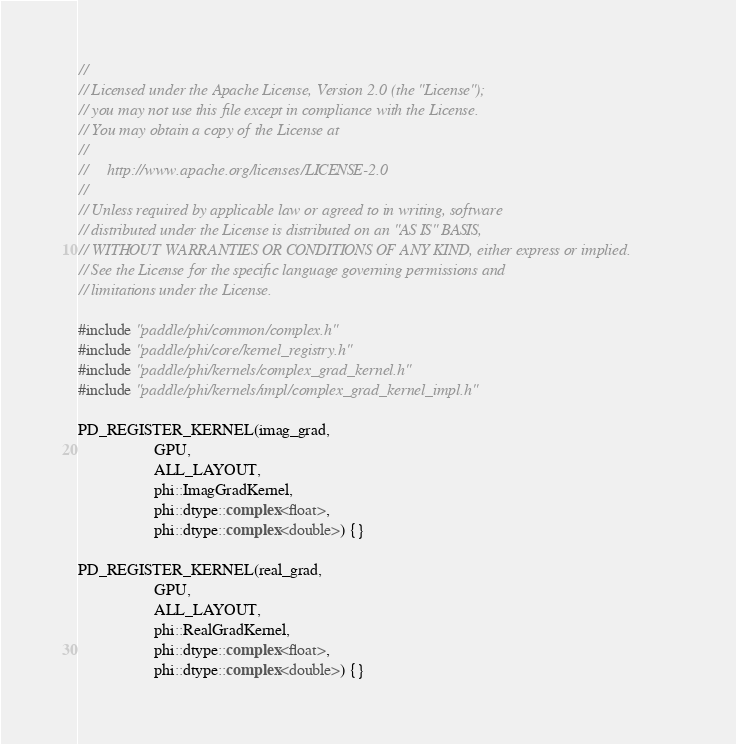Convert code to text. <code><loc_0><loc_0><loc_500><loc_500><_Cuda_>//
// Licensed under the Apache License, Version 2.0 (the "License");
// you may not use this file except in compliance with the License.
// You may obtain a copy of the License at
//
//     http://www.apache.org/licenses/LICENSE-2.0
//
// Unless required by applicable law or agreed to in writing, software
// distributed under the License is distributed on an "AS IS" BASIS,
// WITHOUT WARRANTIES OR CONDITIONS OF ANY KIND, either express or implied.
// See the License for the specific language governing permissions and
// limitations under the License.

#include "paddle/phi/common/complex.h"
#include "paddle/phi/core/kernel_registry.h"
#include "paddle/phi/kernels/complex_grad_kernel.h"
#include "paddle/phi/kernels/impl/complex_grad_kernel_impl.h"

PD_REGISTER_KERNEL(imag_grad,
                   GPU,
                   ALL_LAYOUT,
                   phi::ImagGradKernel,
                   phi::dtype::complex<float>,
                   phi::dtype::complex<double>) {}

PD_REGISTER_KERNEL(real_grad,
                   GPU,
                   ALL_LAYOUT,
                   phi::RealGradKernel,
                   phi::dtype::complex<float>,
                   phi::dtype::complex<double>) {}
</code> 